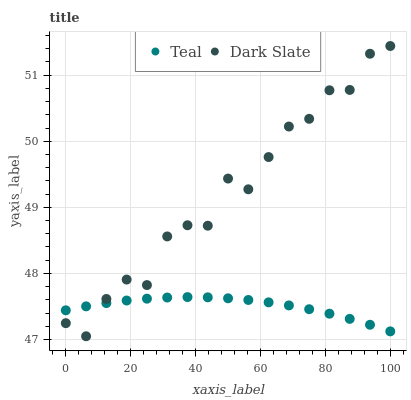Does Teal have the minimum area under the curve?
Answer yes or no. Yes. Does Dark Slate have the maximum area under the curve?
Answer yes or no. Yes. Does Teal have the maximum area under the curve?
Answer yes or no. No. Is Teal the smoothest?
Answer yes or no. Yes. Is Dark Slate the roughest?
Answer yes or no. Yes. Is Teal the roughest?
Answer yes or no. No. Does Dark Slate have the lowest value?
Answer yes or no. Yes. Does Teal have the lowest value?
Answer yes or no. No. Does Dark Slate have the highest value?
Answer yes or no. Yes. Does Teal have the highest value?
Answer yes or no. No. Does Teal intersect Dark Slate?
Answer yes or no. Yes. Is Teal less than Dark Slate?
Answer yes or no. No. Is Teal greater than Dark Slate?
Answer yes or no. No. 